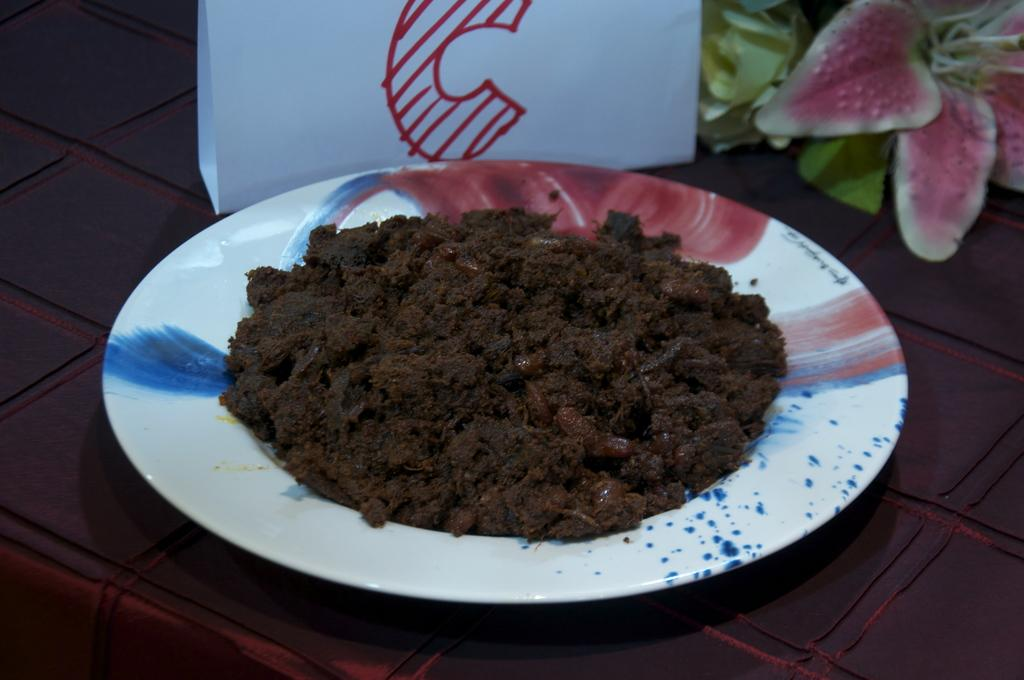What is on the plate in the image? There is food on a plate in the image. What can be seen in the background of the image? There is an artificial flower in the background of the image. Where are the food and flower located? The food and flower are placed on a table. What color is the crayon used to draw the police officer in the image? There is no crayon or police officer present in the image. 